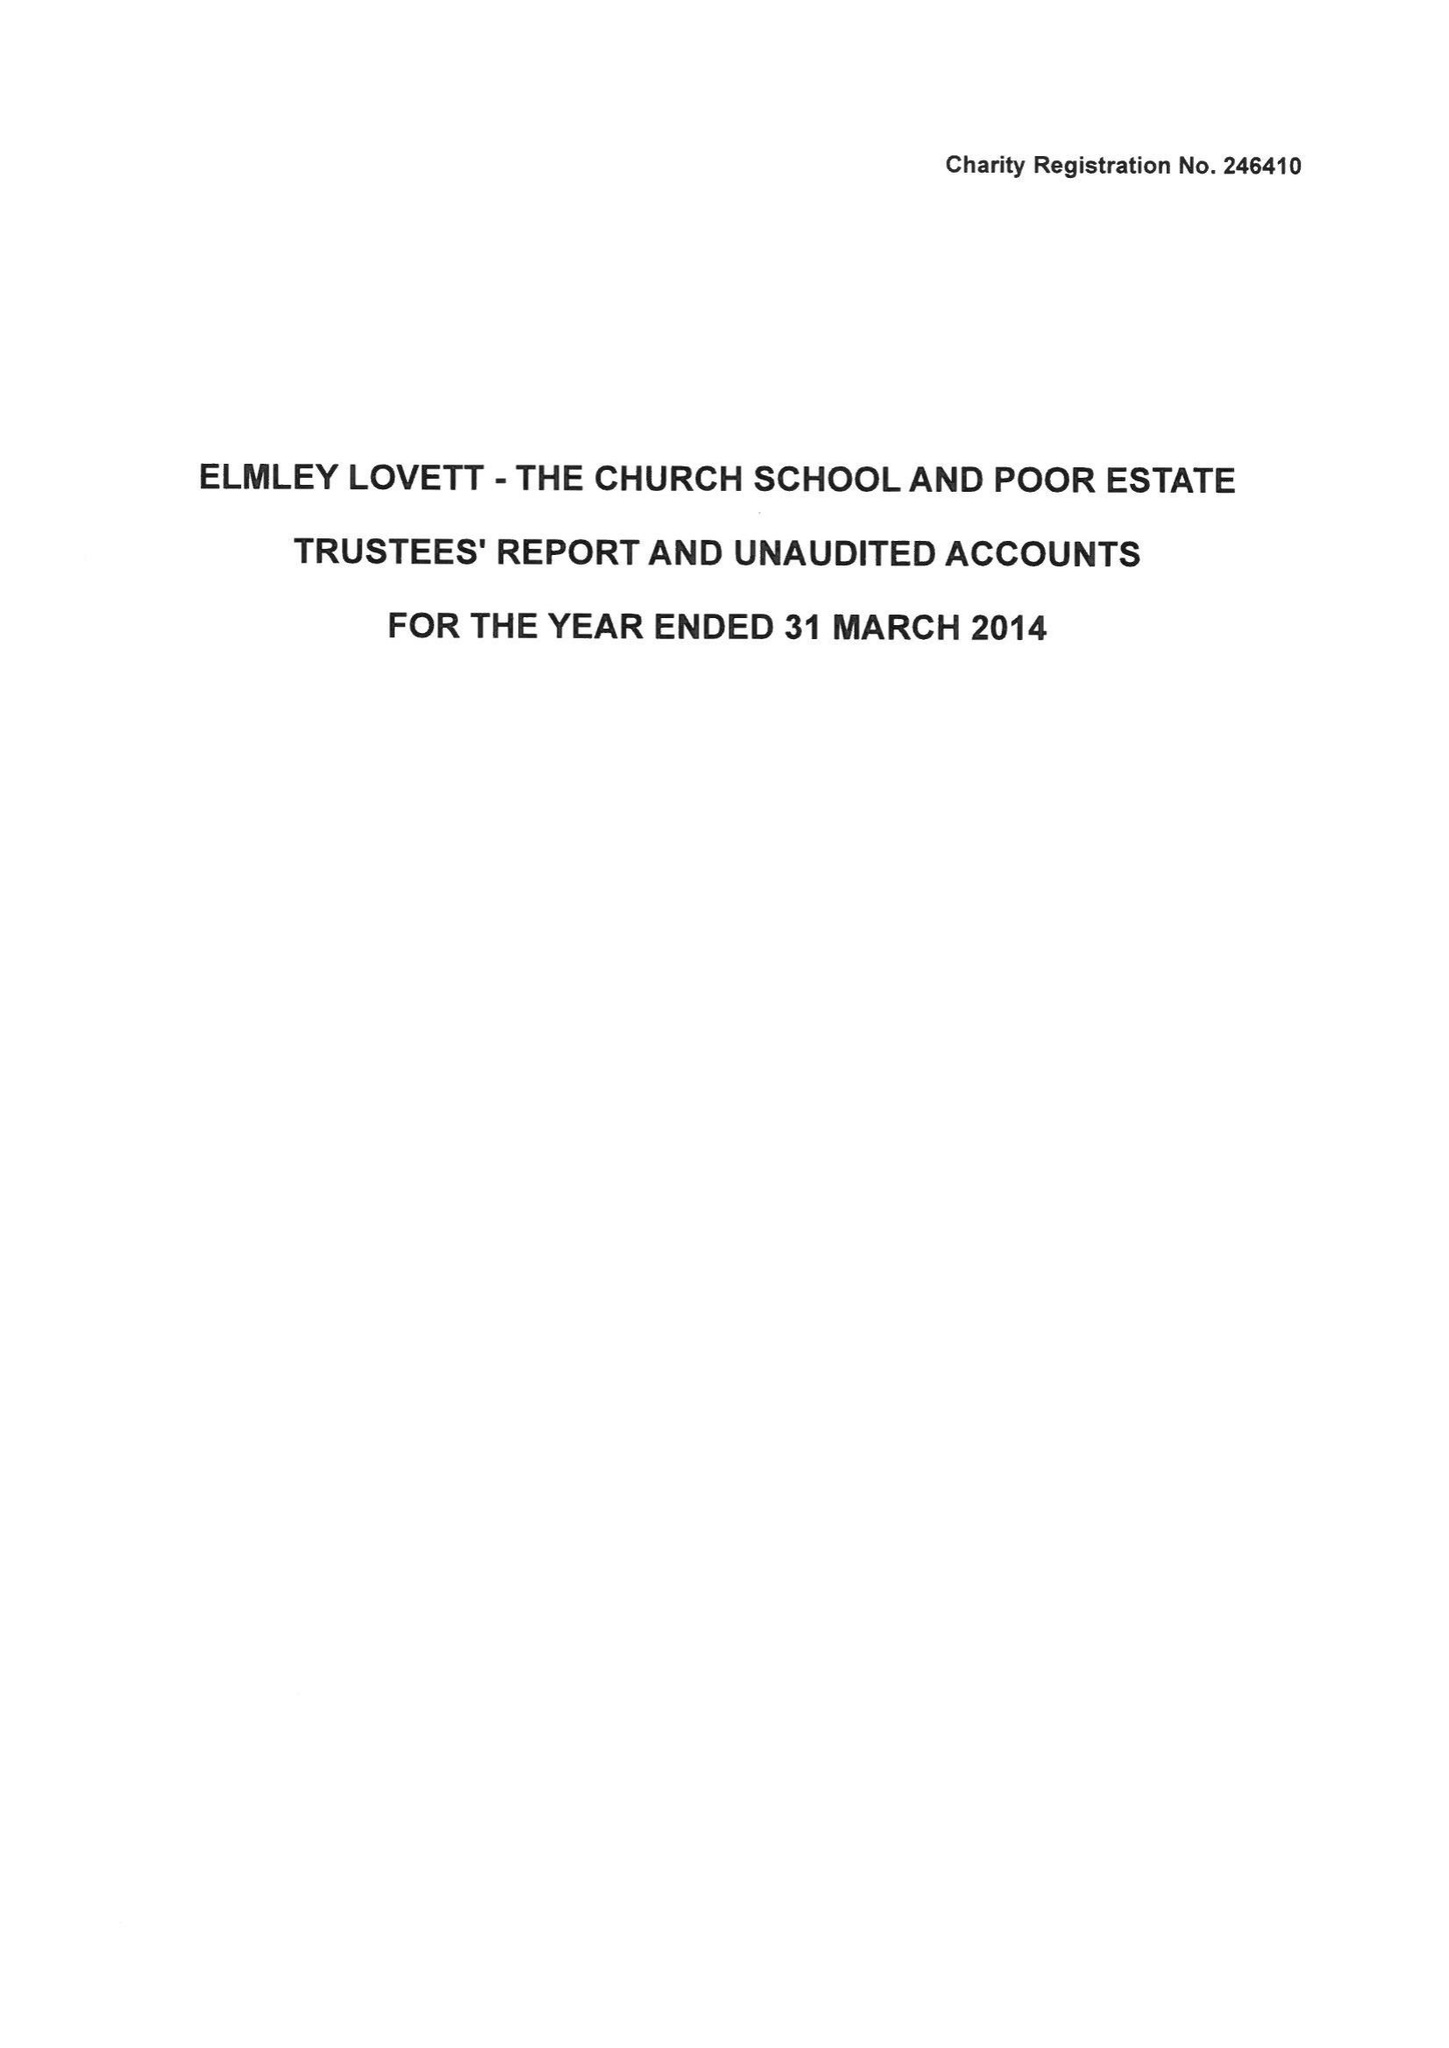What is the value for the address__post_town?
Answer the question using a single word or phrase. DROITWICH 